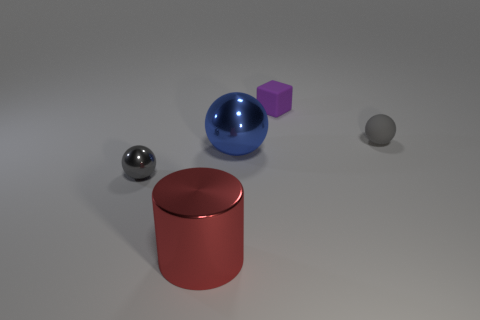Subtract all gray metallic balls. How many balls are left? 2 Add 3 big red shiny cylinders. How many objects exist? 8 Subtract all blue balls. How many balls are left? 2 Subtract 1 cylinders. How many cylinders are left? 0 Add 1 tiny purple rubber cubes. How many tiny purple rubber cubes are left? 2 Add 5 big yellow matte cylinders. How many big yellow matte cylinders exist? 5 Subtract 1 blue spheres. How many objects are left? 4 Subtract all cylinders. How many objects are left? 4 Subtract all green balls. Subtract all blue cylinders. How many balls are left? 3 Subtract all cyan blocks. How many blue spheres are left? 1 